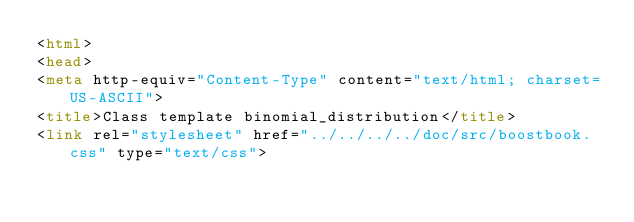<code> <loc_0><loc_0><loc_500><loc_500><_HTML_><html>
<head>
<meta http-equiv="Content-Type" content="text/html; charset=US-ASCII">
<title>Class template binomial_distribution</title>
<link rel="stylesheet" href="../../../../doc/src/boostbook.css" type="text/css"></code> 